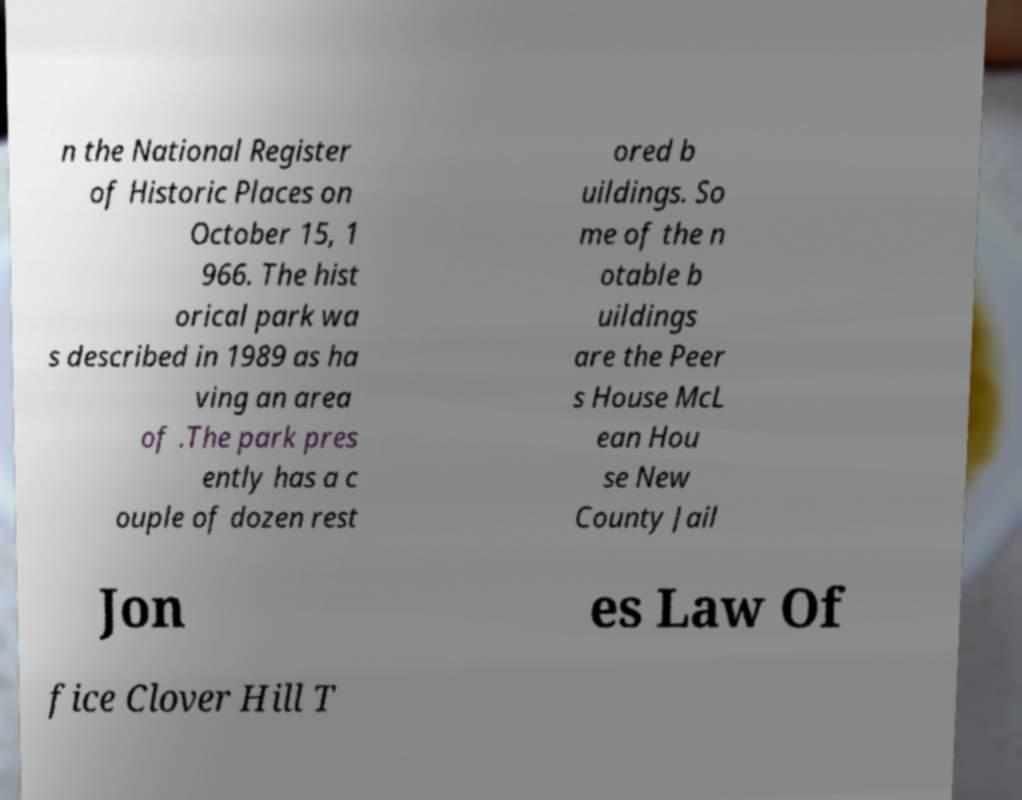Can you accurately transcribe the text from the provided image for me? n the National Register of Historic Places on October 15, 1 966. The hist orical park wa s described in 1989 as ha ving an area of .The park pres ently has a c ouple of dozen rest ored b uildings. So me of the n otable b uildings are the Peer s House McL ean Hou se New County Jail Jon es Law Of fice Clover Hill T 